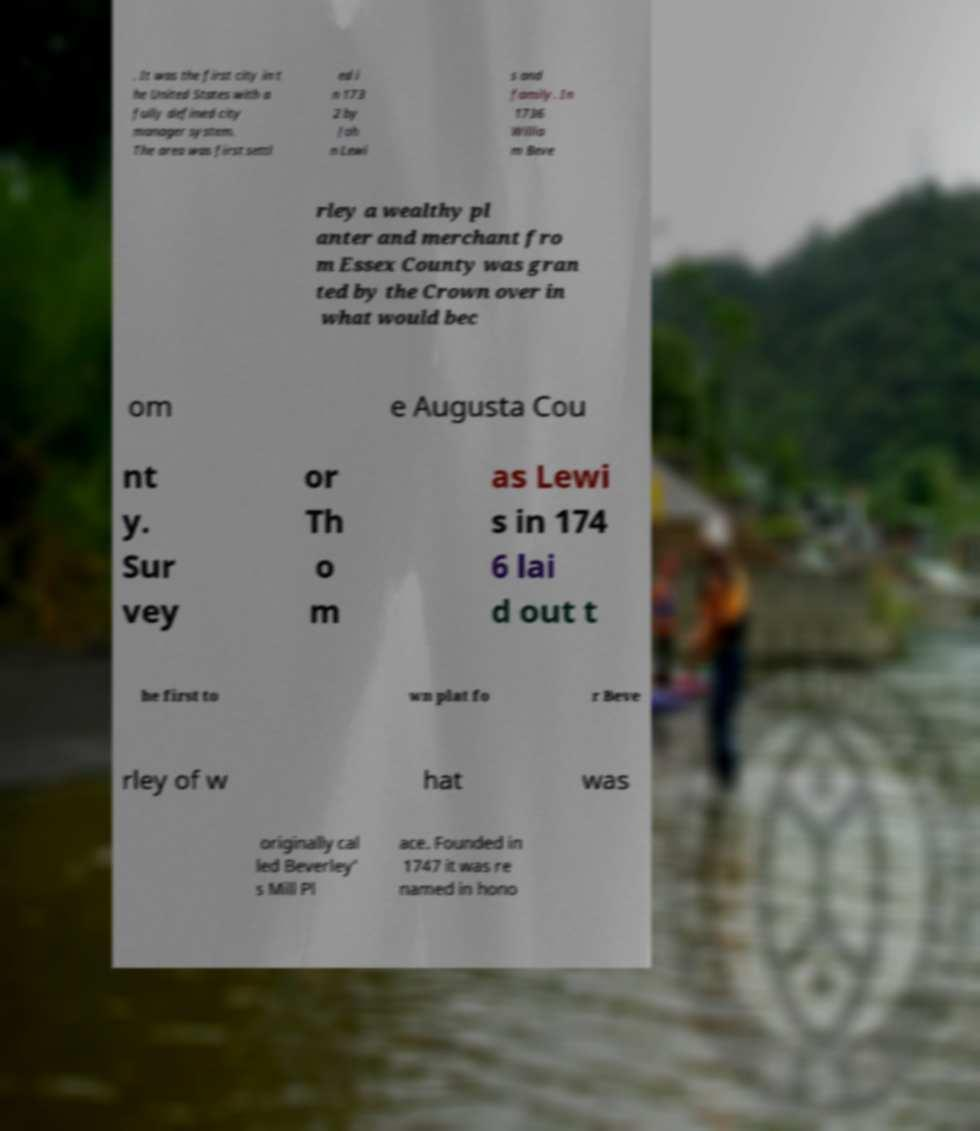Can you accurately transcribe the text from the provided image for me? . It was the first city in t he United States with a fully defined city manager system. The area was first settl ed i n 173 2 by Joh n Lewi s and family. In 1736 Willia m Beve rley a wealthy pl anter and merchant fro m Essex County was gran ted by the Crown over in what would bec om e Augusta Cou nt y. Sur vey or Th o m as Lewi s in 174 6 lai d out t he first to wn plat fo r Beve rley of w hat was originally cal led Beverley' s Mill Pl ace. Founded in 1747 it was re named in hono 